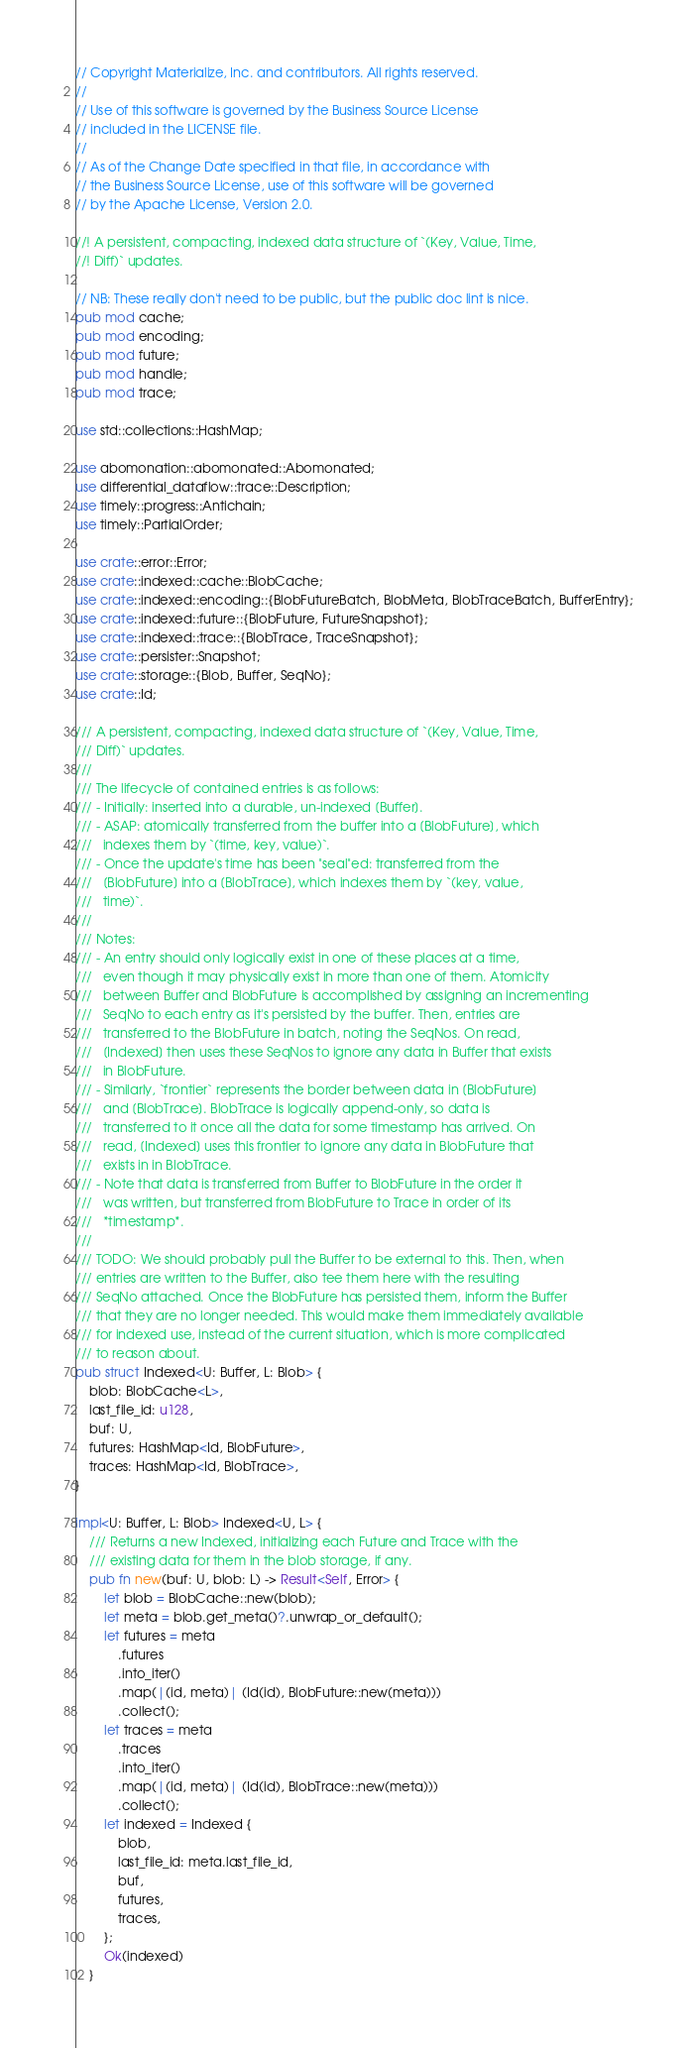Convert code to text. <code><loc_0><loc_0><loc_500><loc_500><_Rust_>// Copyright Materialize, Inc. and contributors. All rights reserved.
//
// Use of this software is governed by the Business Source License
// included in the LICENSE file.
//
// As of the Change Date specified in that file, in accordance with
// the Business Source License, use of this software will be governed
// by the Apache License, Version 2.0.

//! A persistent, compacting, indexed data structure of `(Key, Value, Time,
//! Diff)` updates.

// NB: These really don't need to be public, but the public doc lint is nice.
pub mod cache;
pub mod encoding;
pub mod future;
pub mod handle;
pub mod trace;

use std::collections::HashMap;

use abomonation::abomonated::Abomonated;
use differential_dataflow::trace::Description;
use timely::progress::Antichain;
use timely::PartialOrder;

use crate::error::Error;
use crate::indexed::cache::BlobCache;
use crate::indexed::encoding::{BlobFutureBatch, BlobMeta, BlobTraceBatch, BufferEntry};
use crate::indexed::future::{BlobFuture, FutureSnapshot};
use crate::indexed::trace::{BlobTrace, TraceSnapshot};
use crate::persister::Snapshot;
use crate::storage::{Blob, Buffer, SeqNo};
use crate::Id;

/// A persistent, compacting, indexed data structure of `(Key, Value, Time,
/// Diff)` updates.
///
/// The lifecycle of contained entries is as follows:
/// - Initially: inserted into a durable, un-indexed [Buffer].
/// - ASAP: atomically transferred from the buffer into a [BlobFuture], which
///   indexes them by `(time, key, value)`.
/// - Once the update's time has been "seal"ed: transferred from the
///   [BlobFuture] into a [BlobTrace], which indexes them by `(key, value,
///   time)`.
///
/// Notes:
/// - An entry should only logically exist in one of these places at a time,
///   even though it may physically exist in more than one of them. Atomicity
///   between Buffer and BlobFuture is accomplished by assigning an incrementing
///   SeqNo to each entry as it's persisted by the buffer. Then, entries are
///   transferred to the BlobFuture in batch, noting the SeqNos. On read,
///   [Indexed] then uses these SeqNos to ignore any data in Buffer that exists
///   in BlobFuture.
/// - Similarly, `frontier` represents the border between data in [BlobFuture]
///   and [BlobTrace]. BlobTrace is logically append-only, so data is
///   transferred to it once all the data for some timestamp has arrived. On
///   read, [Indexed] uses this frontier to ignore any data in BlobFuture that
///   exists in in BlobTrace.
/// - Note that data is transferred from Buffer to BlobFuture in the order it
///   was written, but transferred from BlobFuture to Trace in order of its
///   *timestamp*.
///
/// TODO: We should probably pull the Buffer to be external to this. Then, when
/// entries are written to the Buffer, also tee them here with the resulting
/// SeqNo attached. Once the BlobFuture has persisted them, inform the Buffer
/// that they are no longer needed. This would make them immediately available
/// for indexed use, instead of the current situation, which is more complicated
/// to reason about.
pub struct Indexed<U: Buffer, L: Blob> {
    blob: BlobCache<L>,
    last_file_id: u128,
    buf: U,
    futures: HashMap<Id, BlobFuture>,
    traces: HashMap<Id, BlobTrace>,
}

impl<U: Buffer, L: Blob> Indexed<U, L> {
    /// Returns a new Indexed, initializing each Future and Trace with the
    /// existing data for them in the blob storage, if any.
    pub fn new(buf: U, blob: L) -> Result<Self, Error> {
        let blob = BlobCache::new(blob);
        let meta = blob.get_meta()?.unwrap_or_default();
        let futures = meta
            .futures
            .into_iter()
            .map(|(id, meta)| (Id(id), BlobFuture::new(meta)))
            .collect();
        let traces = meta
            .traces
            .into_iter()
            .map(|(id, meta)| (Id(id), BlobTrace::new(meta)))
            .collect();
        let indexed = Indexed {
            blob,
            last_file_id: meta.last_file_id,
            buf,
            futures,
            traces,
        };
        Ok(indexed)
    }
</code> 